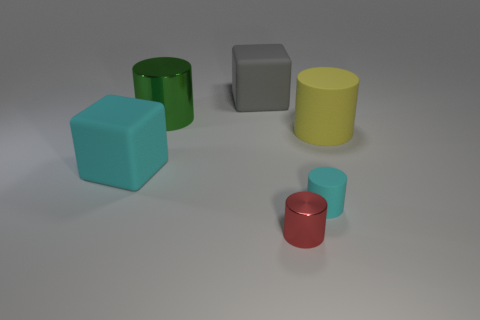Is the number of red shiny things greater than the number of brown blocks?
Make the answer very short. Yes. What number of cylinders are both on the left side of the small red metal thing and right of the small red metal object?
Offer a very short reply. 0. There is a small metal cylinder that is on the right side of the gray block; how many big matte things are on the right side of it?
Your answer should be compact. 1. How many things are either big matte cubes behind the big green object or matte things that are behind the big yellow cylinder?
Your answer should be compact. 1. There is a red object that is the same shape as the yellow object; what is its material?
Provide a succinct answer. Metal. How many things are cyan rubber things that are on the right side of the red metallic cylinder or large cyan objects?
Keep it short and to the point. 2. There is a yellow object that is the same material as the big cyan object; what shape is it?
Make the answer very short. Cylinder. How many other tiny red metallic objects have the same shape as the tiny red object?
Provide a short and direct response. 0. What is the material of the large green thing?
Offer a terse response. Metal. Is the color of the tiny shiny thing the same as the large rubber object that is behind the yellow matte cylinder?
Ensure brevity in your answer.  No. 